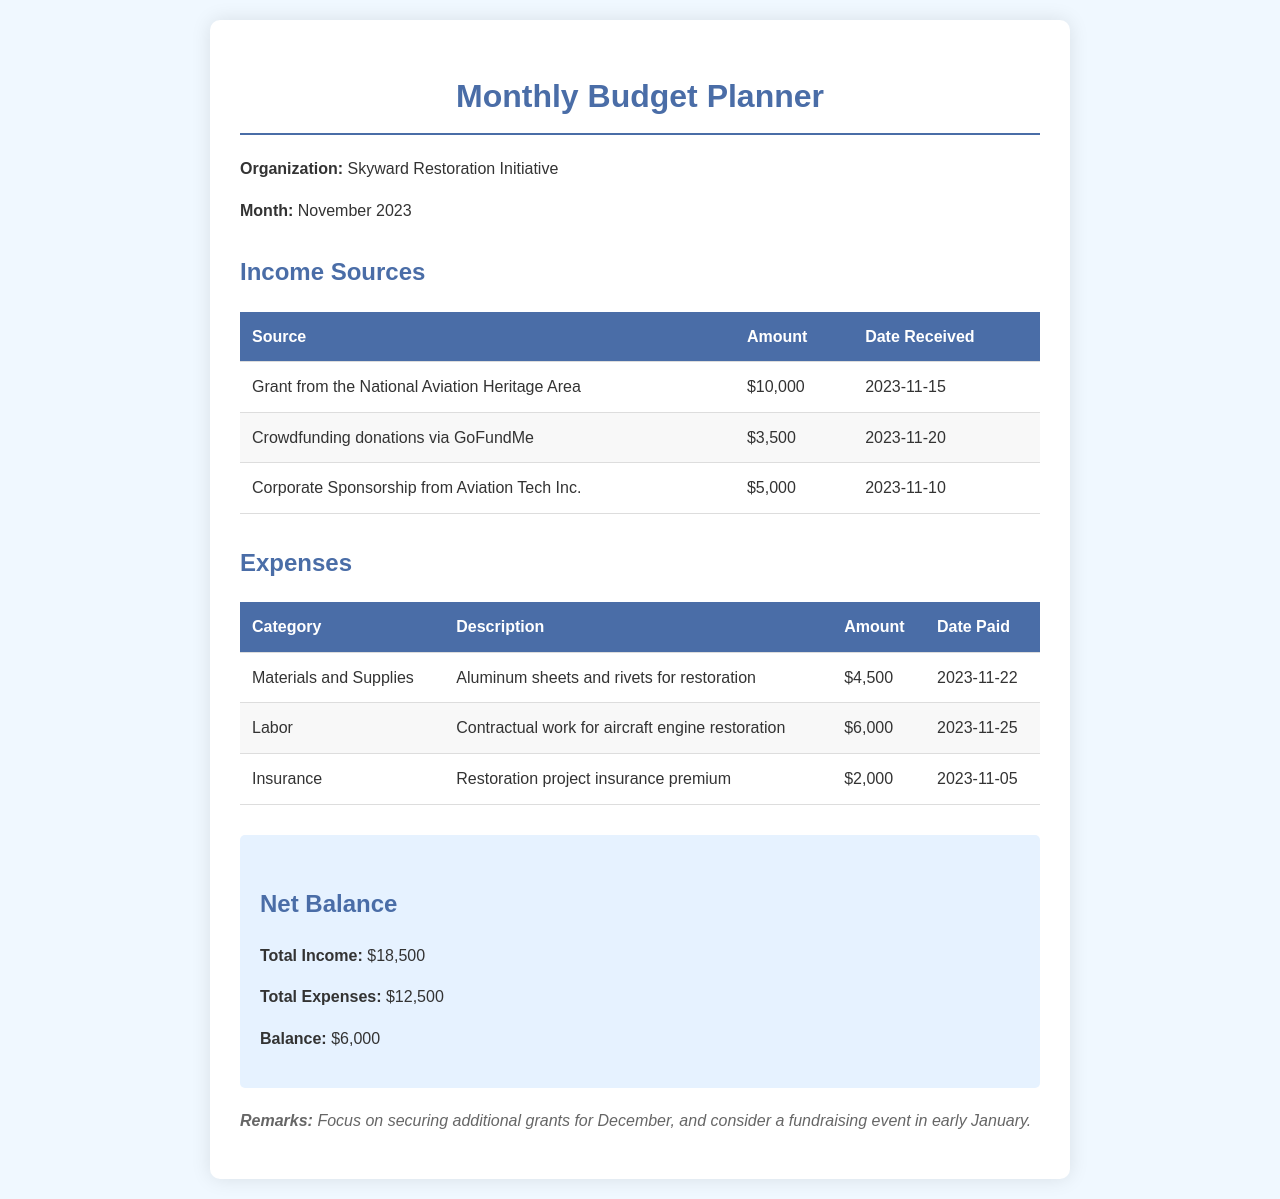What is the total income for November 2023? The total income is the sum of all income sources listed in the document, which is $10,000 + $3,500 + $5,000 = $18,500.
Answer: $18,500 What are the materials purchased for restoration? The materials purchased are mentioned in the expenses section, specifically aluminum sheets and rivets.
Answer: Aluminum sheets and rivets When is the grant from the National Aviation Heritage Area expected to be received? The document provides a date for when this grant will be received, which is November 15, 2023.
Answer: 2023-11-15 How much was spent on labor for the restoration project? The labor expense is detailed in the expenses table with an amount of $6,000.
Answer: $6,000 What is the balance after considering total income and expenses? The balance can be calculated by subtracting total expenses from total income, which is $18,500 - $12,500 = $6,000.
Answer: $6,000 What is the date of payment for the insurance premium? The date when the insurance premium was paid is clearly stated in the expenses section, which is November 5, 2023.
Answer: 2023-11-05 Where are crowdfunding donations sourced from? The document specifies that crowdfunding donations come via GoFundMe.
Answer: GoFundMe What future actions are suggested in the remarks section? The remarks suggest focusing on securing additional grants for December and considering a fundraising event in early January.
Answer: Securing additional grants and fundraising event 